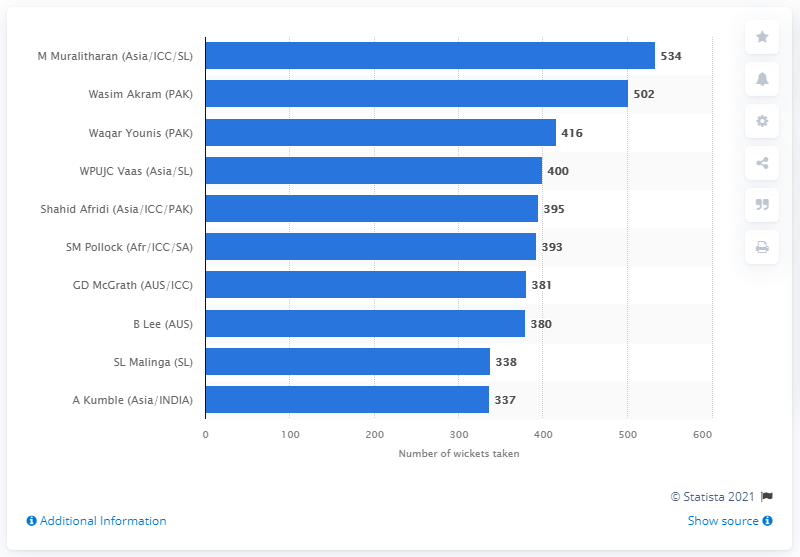Outline some significant characteristics in this image. Muttiah Muralitharan took 534 wickets in his ODI career. 